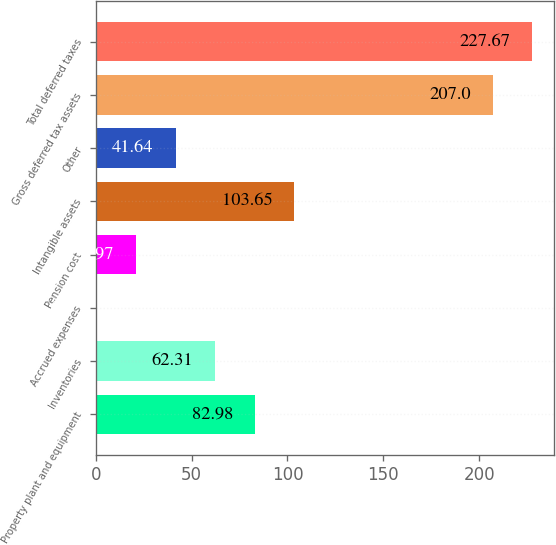<chart> <loc_0><loc_0><loc_500><loc_500><bar_chart><fcel>Property plant and equipment<fcel>Inventories<fcel>Accrued expenses<fcel>Pension cost<fcel>Intangible assets<fcel>Other<fcel>Gross deferred tax assets<fcel>Total deferred taxes<nl><fcel>82.98<fcel>62.31<fcel>0.3<fcel>20.97<fcel>103.65<fcel>41.64<fcel>207<fcel>227.67<nl></chart> 